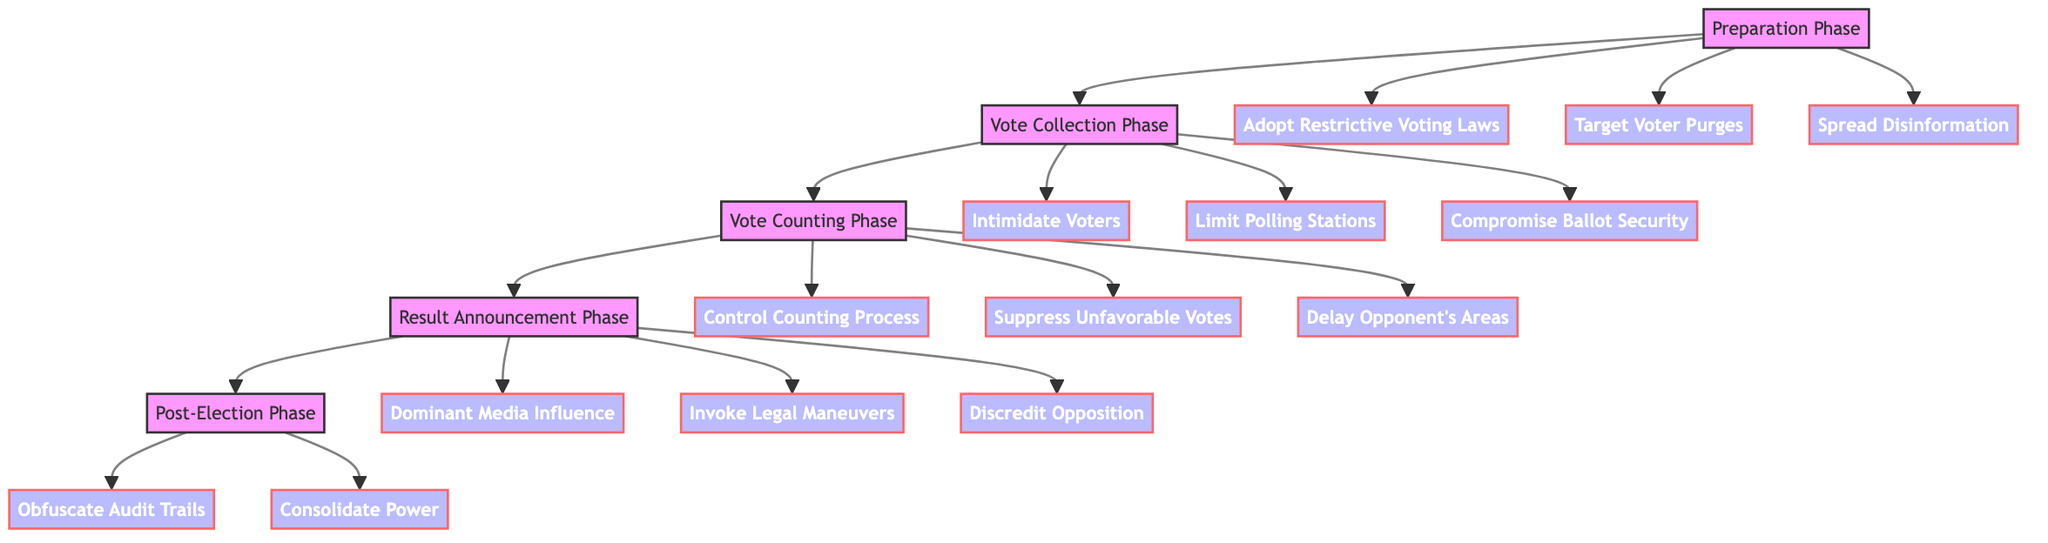What are the four main phases in the diagram? The diagram outlines four main phases: Preparation Phase, Vote Collection Phase, Vote Counting Phase, and Result Announcement Phase.
Answer: Preparation Phase, Vote Collection Phase, Vote Counting Phase, Result Announcement Phase How many sub-elements are under the Vote Collection Phase? There are three sub-elements listed under the Vote Collection Phase: Intimidate Voters, Limit Polling Stations, and Compromise Ballot Security.
Answer: 3 Which sub-element from the Result Announcement Phase refers to controlling media narratives? The sub-element that refers to controlling media narratives is Dominant Media Influence.
Answer: Dominant Media Influence What is the last phase in the manipulation workflow? According to the flow, the last phase in the manipulation workflow is the Post-Election Phase.
Answer: Post-Election Phase Which phase involves discarding ballots under the pretense of minor mistakes? The phase that involves discarding ballots under the pretense of minor mistakes is the Vote Counting Phase, specifically the sub-element Suppress Unfavorable Votes.
Answer: Vote Counting Phase What is the primary action taken during the Preparation Phase to limit voting access? The primary action taken during the Preparation Phase to limit voting access is adopting restrictive voting laws.
Answer: Adopt Restrictive Voting Laws How are polling stations affected in the Vote Collection Phase? In the Vote Collection Phase, polling stations are limited, particularly in areas that are likely to favor opposition candidates, which creates long wait times.
Answer: Limit Polling Stations Which sub-element is intended to undermine electoral legitimacy during the Result Announcement Phase? The sub-element intended to undermine electoral legitimacy during the Result Announcement Phase is Discredit Opposition.
Answer: Discredit Opposition What tactic is employed to slow down counting in areas favoring opposition? The tactic employed to slow down counting in areas favoring the opposition is Delay Opponent's Areas.
Answer: Delay Opponent's Areas 